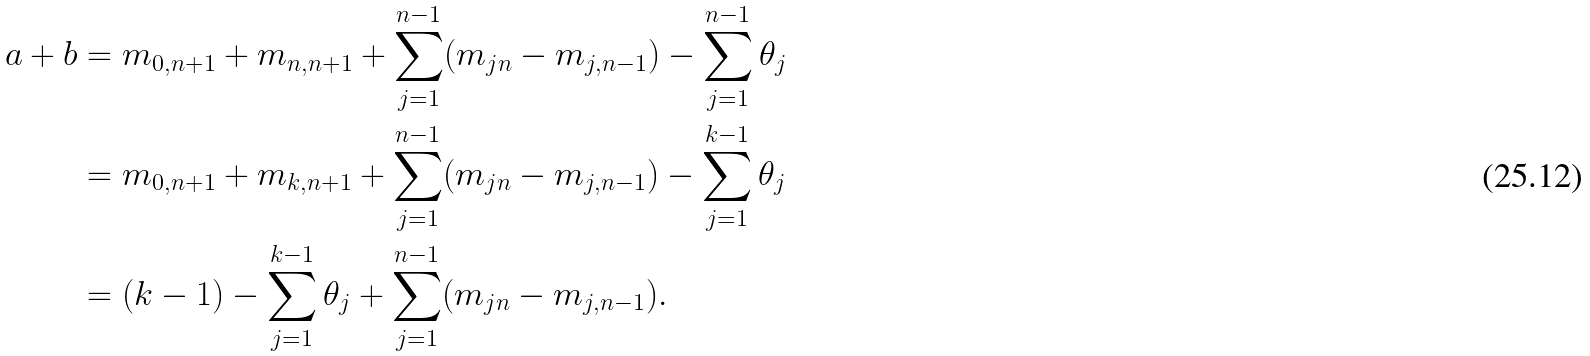<formula> <loc_0><loc_0><loc_500><loc_500>a + b & = m _ { 0 , n + 1 } + m _ { n , n + 1 } + \sum _ { j = 1 } ^ { n - 1 } ( m _ { j n } - m _ { j , n - 1 } ) - \sum _ { j = 1 } ^ { n - 1 } \theta _ { j } \\ & = m _ { 0 , n + 1 } + m _ { k , n + 1 } + \sum _ { j = 1 } ^ { n - 1 } ( m _ { j n } - m _ { j , n - 1 } ) - \sum _ { j = 1 } ^ { k - 1 } \theta _ { j } \\ & = ( k - 1 ) - \sum _ { j = 1 } ^ { k - 1 } \theta _ { j } + \sum _ { j = 1 } ^ { n - 1 } ( m _ { j n } - m _ { j , n - 1 } ) . \\</formula> 